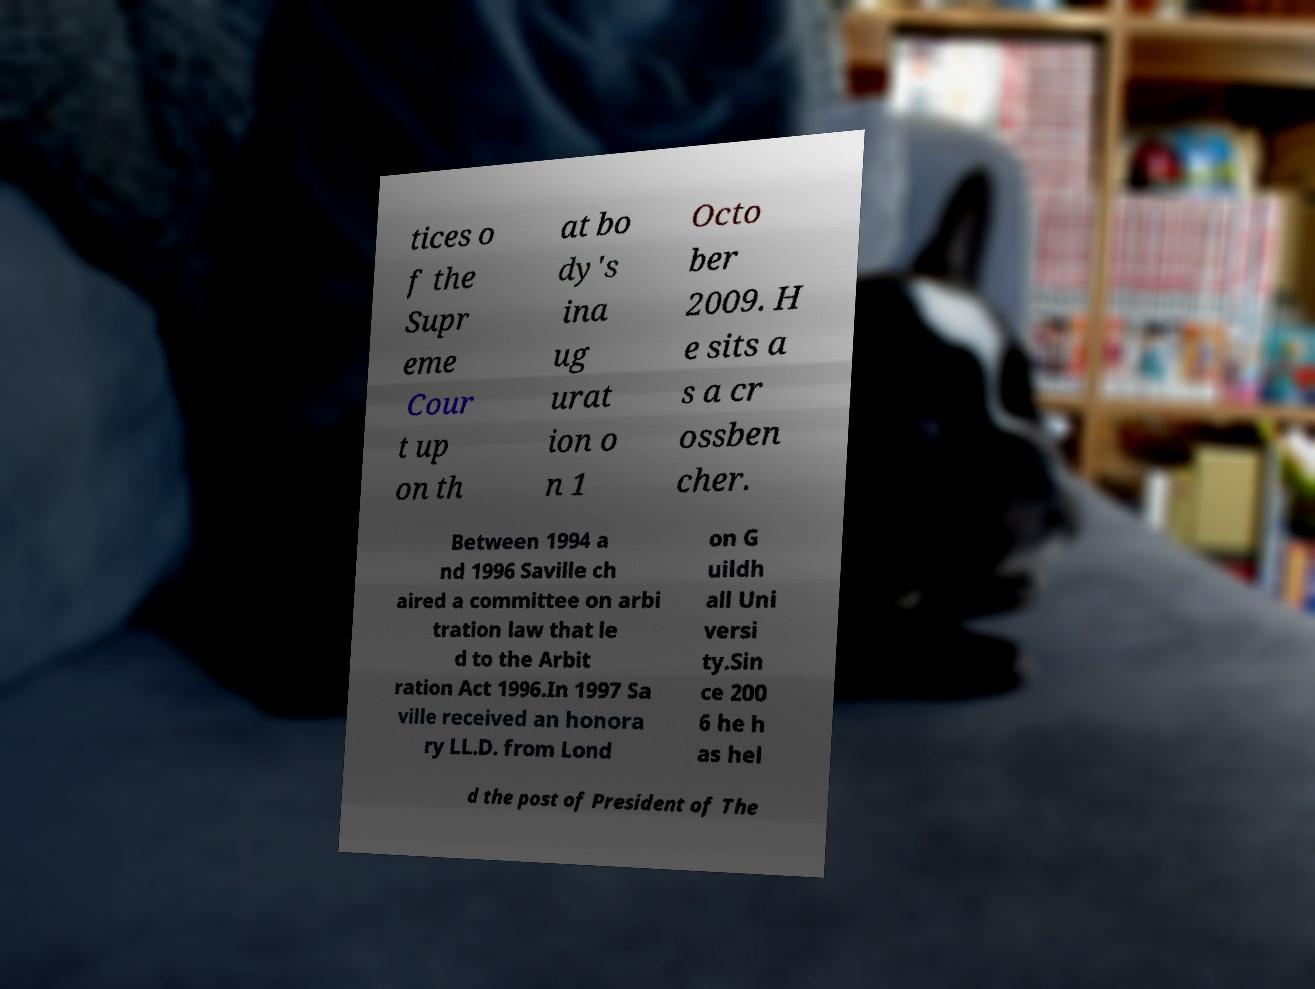Could you extract and type out the text from this image? tices o f the Supr eme Cour t up on th at bo dy's ina ug urat ion o n 1 Octo ber 2009. H e sits a s a cr ossben cher. Between 1994 a nd 1996 Saville ch aired a committee on arbi tration law that le d to the Arbit ration Act 1996.In 1997 Sa ville received an honora ry LL.D. from Lond on G uildh all Uni versi ty.Sin ce 200 6 he h as hel d the post of President of The 